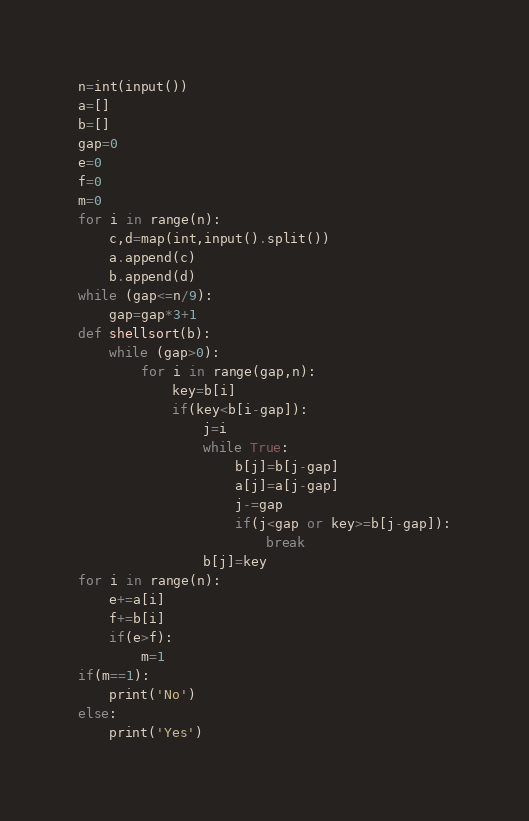Convert code to text. <code><loc_0><loc_0><loc_500><loc_500><_Python_>n=int(input())
a=[]
b=[]
gap=0
e=0
f=0
m=0
for i in range(n):
    c,d=map(int,input().split())
    a.append(c)
    b.append(d)
while (gap<=n/9):
    gap=gap*3+1
def shellsort(b):
    while (gap>0):
        for i in range(gap,n):
            key=b[i]
            if(key<b[i-gap]):
                j=i
                while True:
                    b[j]=b[j-gap]
                    a[j]=a[j-gap]
                    j-=gap
                    if(j<gap or key>=b[j-gap]):
                        break
                b[j]=key
for i in range(n):
    e+=a[i]
    f+=b[i]
    if(e>f):
        m=1
if(m==1):
    print('No')
else:
    print('Yes')
</code> 